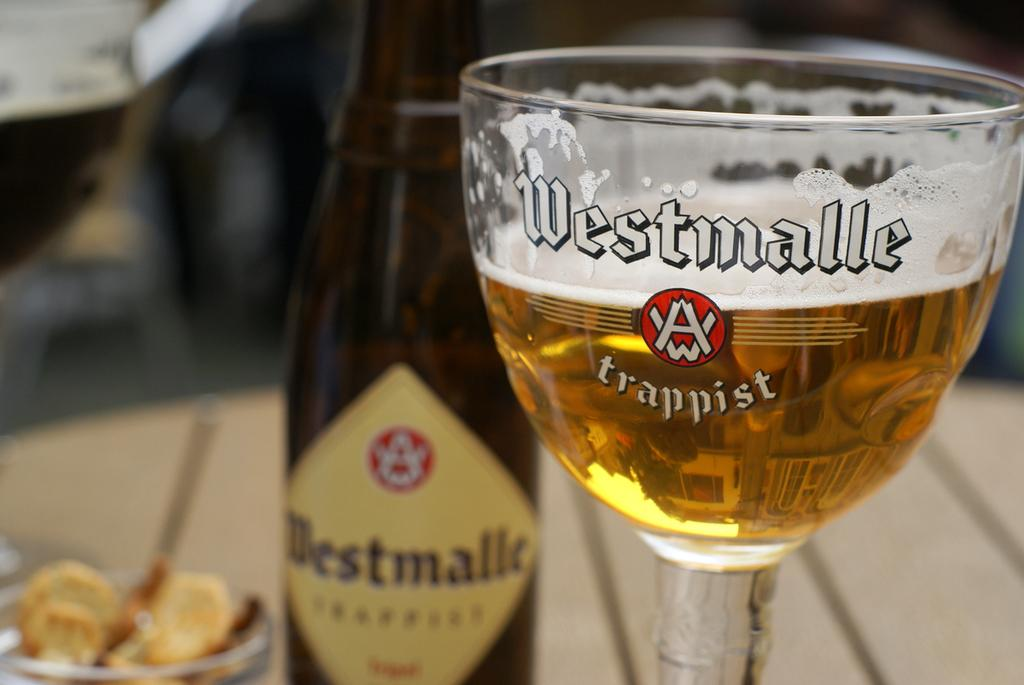<image>
Summarize the visual content of the image. A bottle of Westmalle Trappist is on a table behind a half full glass with the same name and logo on it. 